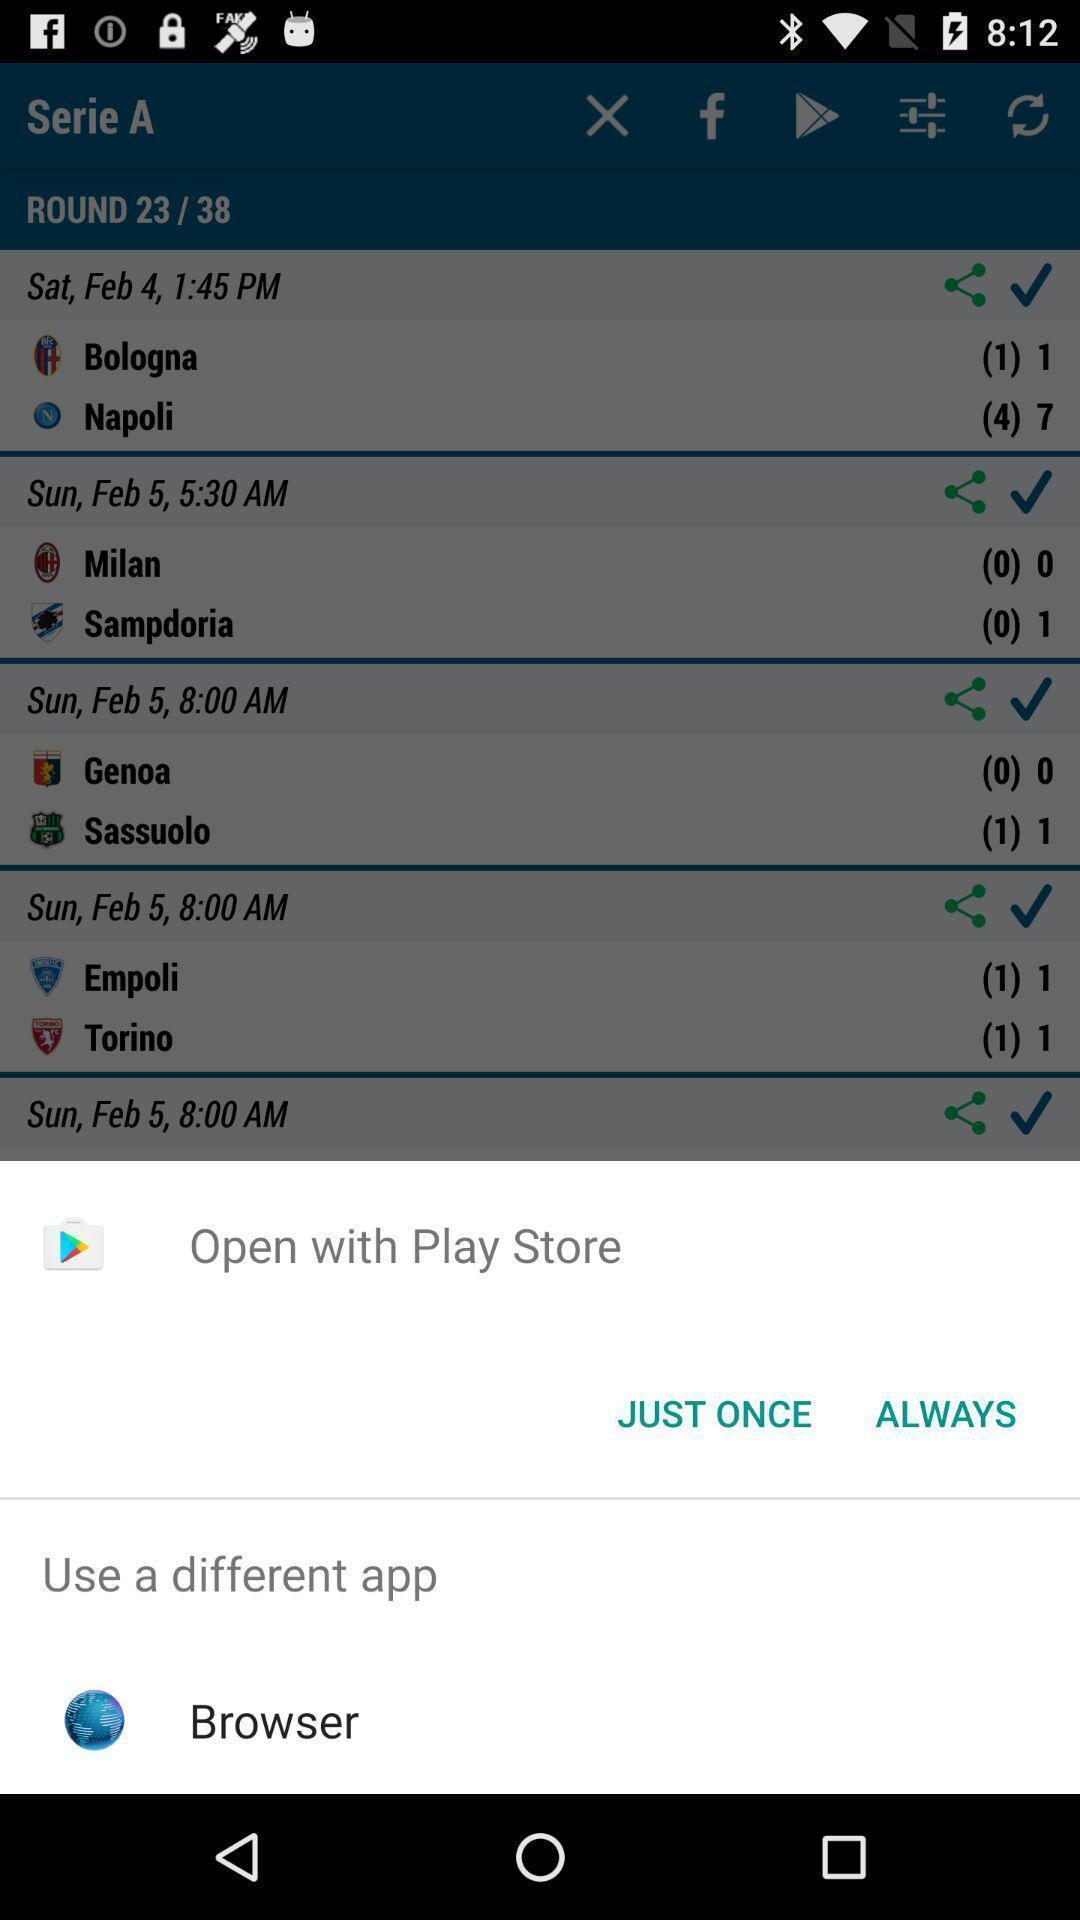Tell me about the visual elements in this screen capture. Widget showing two browsing options. 